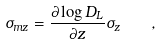<formula> <loc_0><loc_0><loc_500><loc_500>\sigma _ { m z } = \frac { \partial \log D _ { L } } { \partial z } \sigma _ { z } \quad ,</formula> 